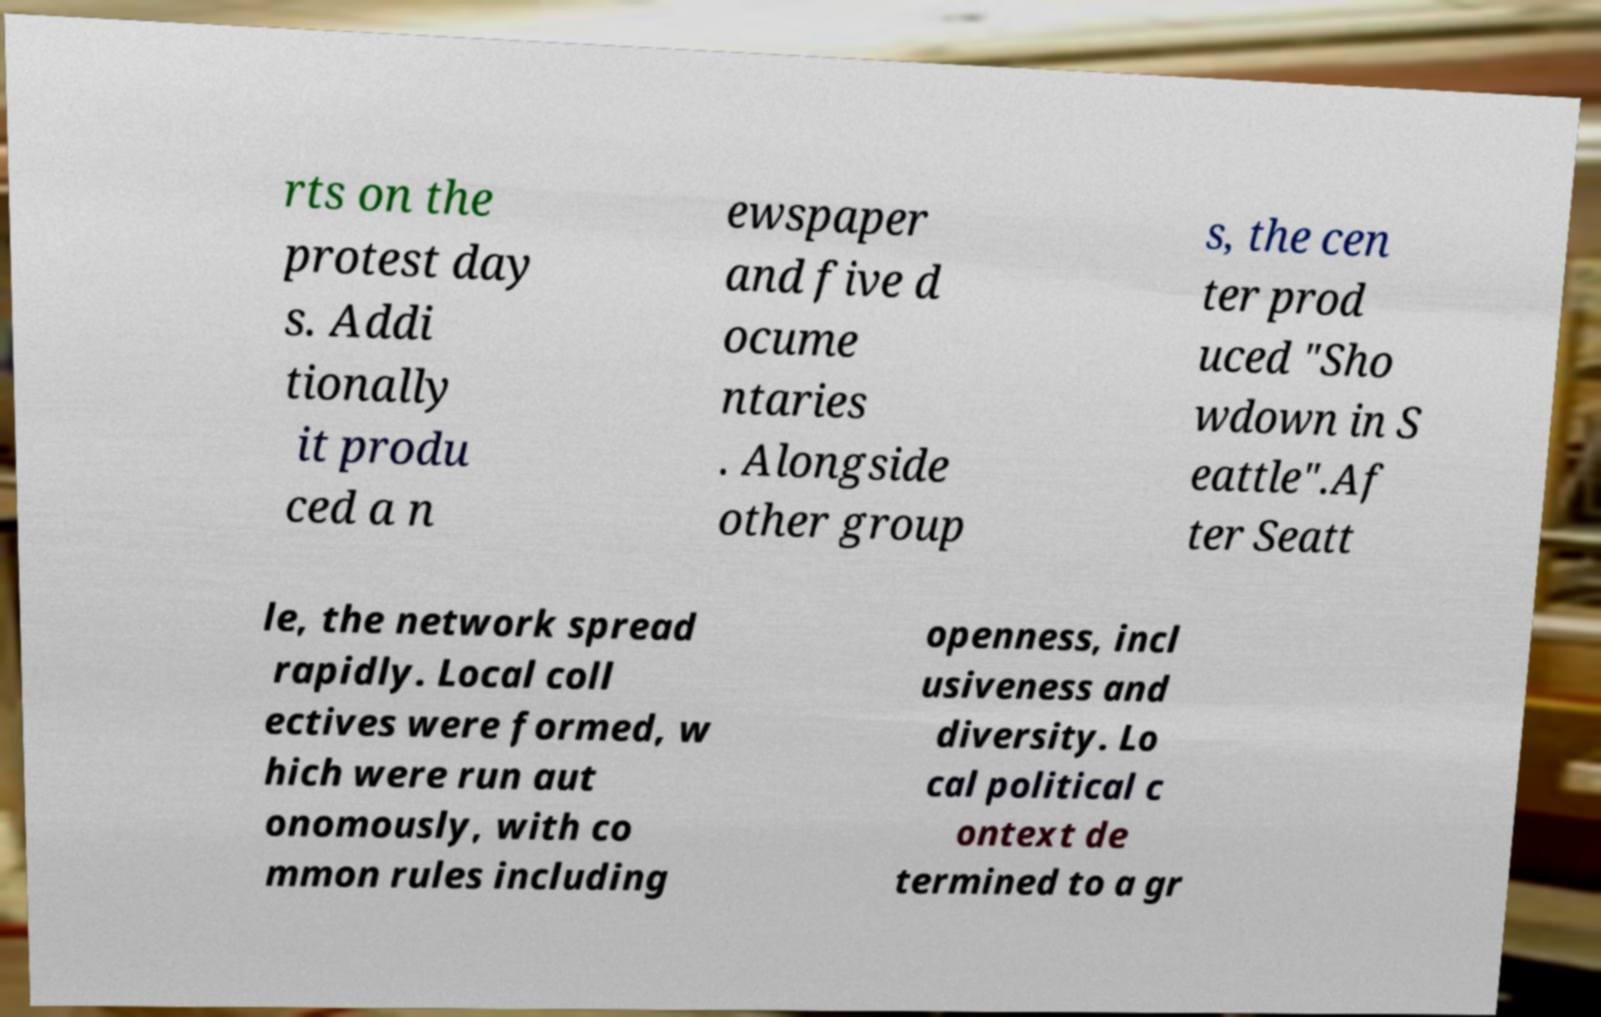What messages or text are displayed in this image? I need them in a readable, typed format. rts on the protest day s. Addi tionally it produ ced a n ewspaper and five d ocume ntaries . Alongside other group s, the cen ter prod uced "Sho wdown in S eattle".Af ter Seatt le, the network spread rapidly. Local coll ectives were formed, w hich were run aut onomously, with co mmon rules including openness, incl usiveness and diversity. Lo cal political c ontext de termined to a gr 